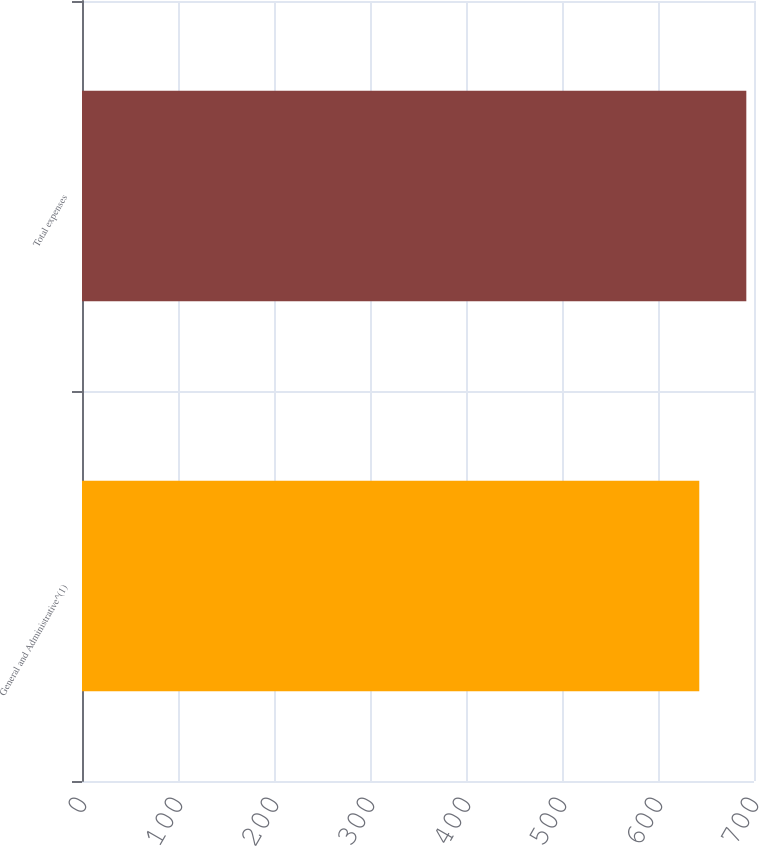<chart> <loc_0><loc_0><loc_500><loc_500><bar_chart><fcel>General and Administrative^(1)<fcel>Total expenses<nl><fcel>643<fcel>692<nl></chart> 